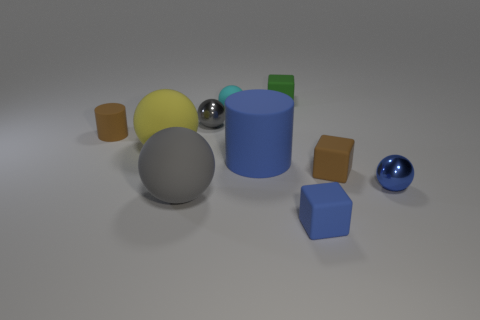Subtract all large gray rubber spheres. How many spheres are left? 4 Subtract all red cubes. How many gray balls are left? 2 Subtract 2 cylinders. How many cylinders are left? 0 Subtract all blue cylinders. How many cylinders are left? 1 Subtract 0 red cubes. How many objects are left? 10 Subtract all cylinders. How many objects are left? 8 Subtract all brown blocks. Subtract all gray spheres. How many blocks are left? 2 Subtract all tiny cylinders. Subtract all green metal balls. How many objects are left? 9 Add 2 tiny gray spheres. How many tiny gray spheres are left? 3 Add 3 blue cylinders. How many blue cylinders exist? 4 